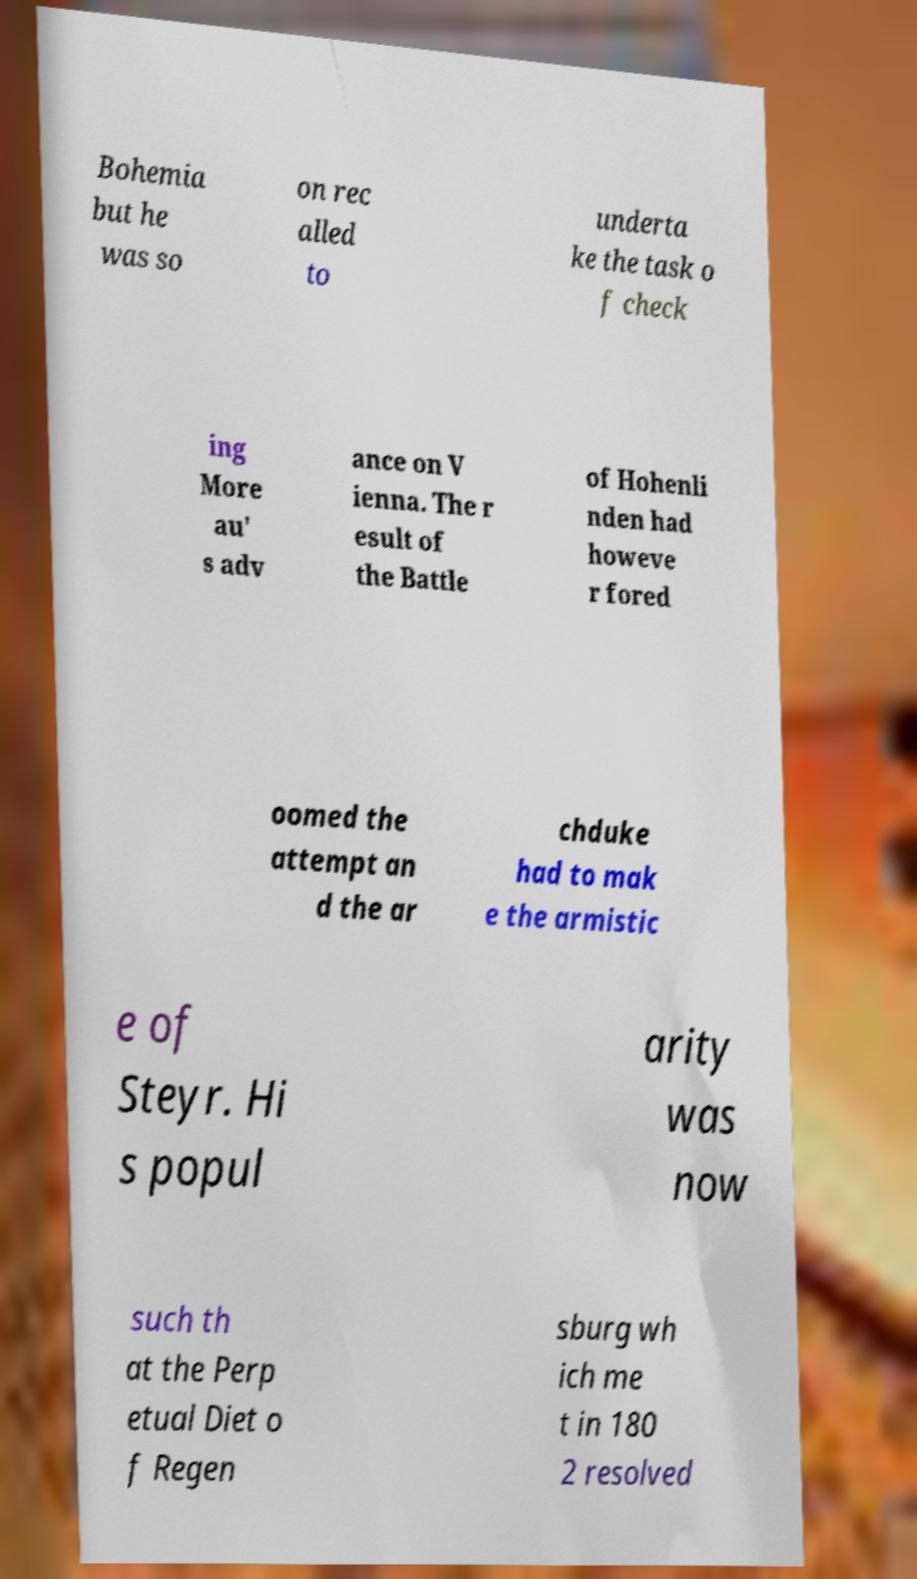Could you assist in decoding the text presented in this image and type it out clearly? Bohemia but he was so on rec alled to underta ke the task o f check ing More au' s adv ance on V ienna. The r esult of the Battle of Hohenli nden had howeve r fored oomed the attempt an d the ar chduke had to mak e the armistic e of Steyr. Hi s popul arity was now such th at the Perp etual Diet o f Regen sburg wh ich me t in 180 2 resolved 